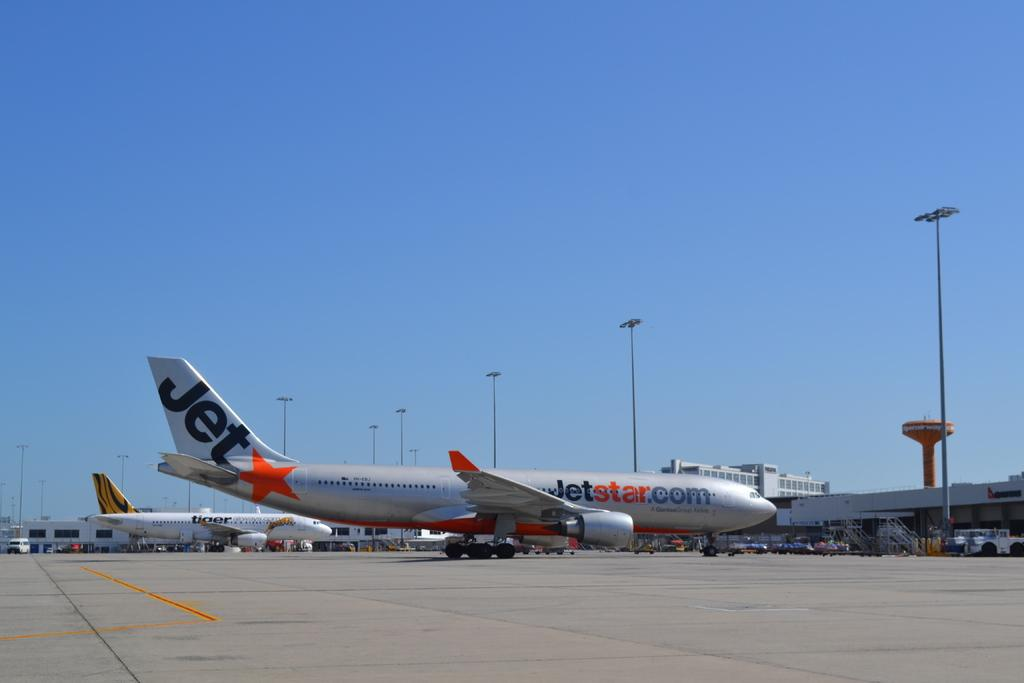<image>
Share a concise interpretation of the image provided. a plane with the word jet on the tail 